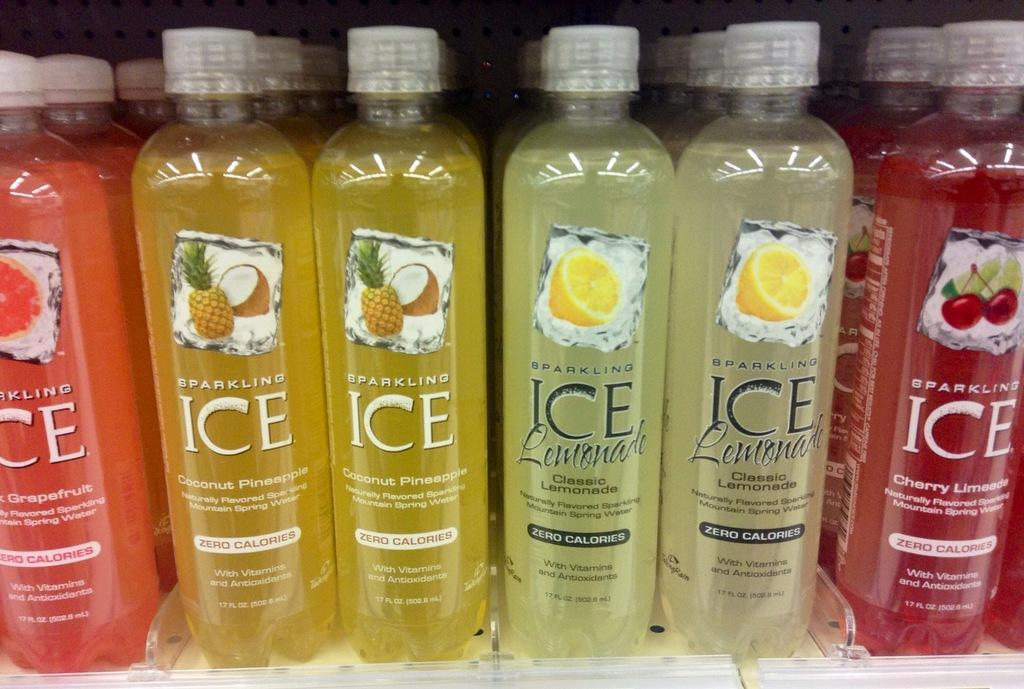<image>
Offer a succinct explanation of the picture presented. Bottles of various colors on a shelf with the words sparkling ICE lemonade written on them. 